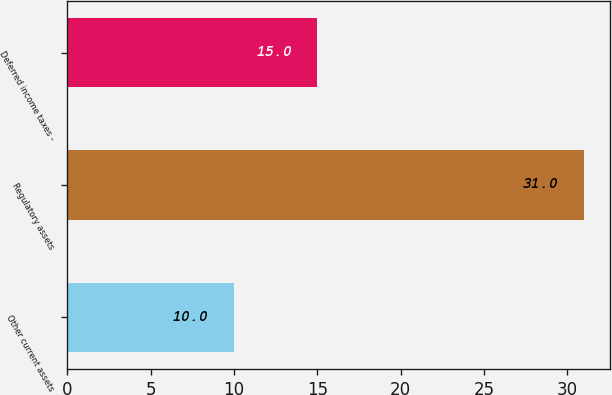<chart> <loc_0><loc_0><loc_500><loc_500><bar_chart><fcel>Other current assets<fcel>Regulatory assets<fcel>Deferred income taxes -<nl><fcel>10<fcel>31<fcel>15<nl></chart> 